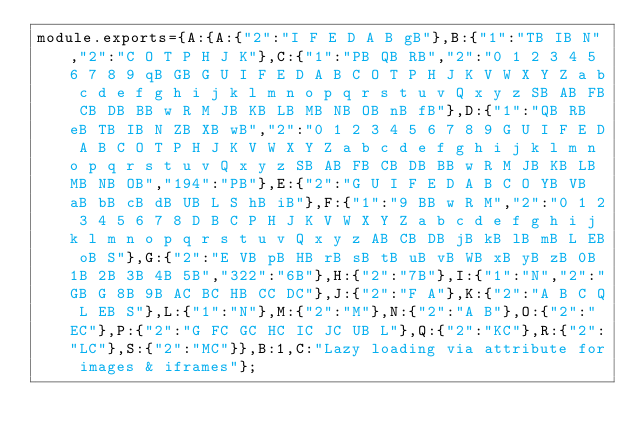Convert code to text. <code><loc_0><loc_0><loc_500><loc_500><_JavaScript_>module.exports={A:{A:{"2":"I F E D A B gB"},B:{"1":"TB IB N","2":"C O T P H J K"},C:{"1":"PB QB RB","2":"0 1 2 3 4 5 6 7 8 9 qB GB G U I F E D A B C O T P H J K V W X Y Z a b c d e f g h i j k l m n o p q r s t u v Q x y z SB AB FB CB DB BB w R M JB KB LB MB NB OB nB fB"},D:{"1":"QB RB eB TB IB N ZB XB wB","2":"0 1 2 3 4 5 6 7 8 9 G U I F E D A B C O T P H J K V W X Y Z a b c d e f g h i j k l m n o p q r s t u v Q x y z SB AB FB CB DB BB w R M JB KB LB MB NB OB","194":"PB"},E:{"2":"G U I F E D A B C O YB VB aB bB cB dB UB L S hB iB"},F:{"1":"9 BB w R M","2":"0 1 2 3 4 5 6 7 8 D B C P H J K V W X Y Z a b c d e f g h i j k l m n o p q r s t u v Q x y z AB CB DB jB kB lB mB L EB oB S"},G:{"2":"E VB pB HB rB sB tB uB vB WB xB yB zB 0B 1B 2B 3B 4B 5B","322":"6B"},H:{"2":"7B"},I:{"1":"N","2":"GB G 8B 9B AC BC HB CC DC"},J:{"2":"F A"},K:{"2":"A B C Q L EB S"},L:{"1":"N"},M:{"2":"M"},N:{"2":"A B"},O:{"2":"EC"},P:{"2":"G FC GC HC IC JC UB L"},Q:{"2":"KC"},R:{"2":"LC"},S:{"2":"MC"}},B:1,C:"Lazy loading via attribute for images & iframes"};
</code> 